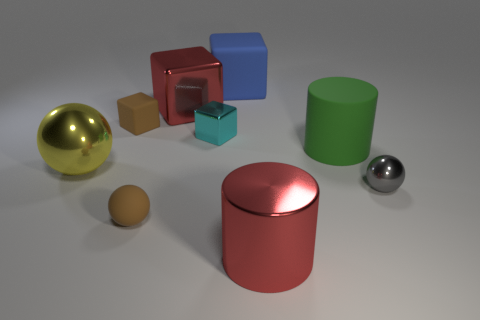The tiny object that is in front of the large rubber cylinder and on the left side of the green cylinder is what color?
Make the answer very short. Brown. What is the material of the brown object that is behind the green object that is on the right side of the brown block?
Offer a very short reply. Rubber. Do the brown matte sphere and the green thing have the same size?
Your answer should be very brief. No. What number of big objects are either metallic spheres or blue cubes?
Your answer should be very brief. 2. There is a tiny brown ball; how many blue objects are in front of it?
Offer a very short reply. 0. Is the number of big metallic blocks that are behind the blue rubber object greater than the number of gray balls?
Provide a short and direct response. No. There is a yellow object that is made of the same material as the small gray ball; what is its shape?
Give a very brief answer. Sphere. The big object on the left side of the small brown matte thing in front of the green matte thing is what color?
Your response must be concise. Yellow. Is the cyan object the same shape as the large blue rubber thing?
Provide a short and direct response. Yes. What is the material of the red thing that is the same shape as the green thing?
Your answer should be compact. Metal. 